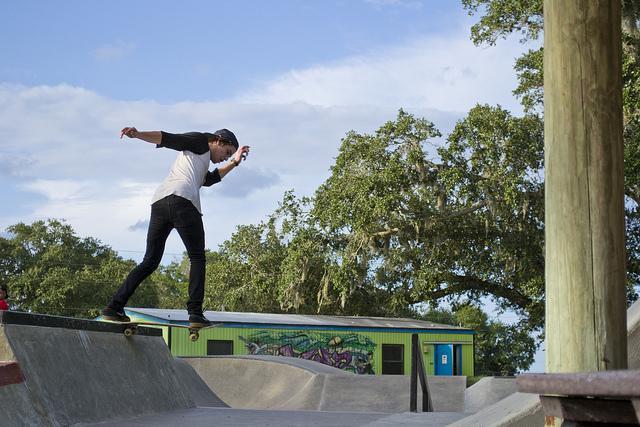How many of the birds are sitting?
Give a very brief answer. 0. 